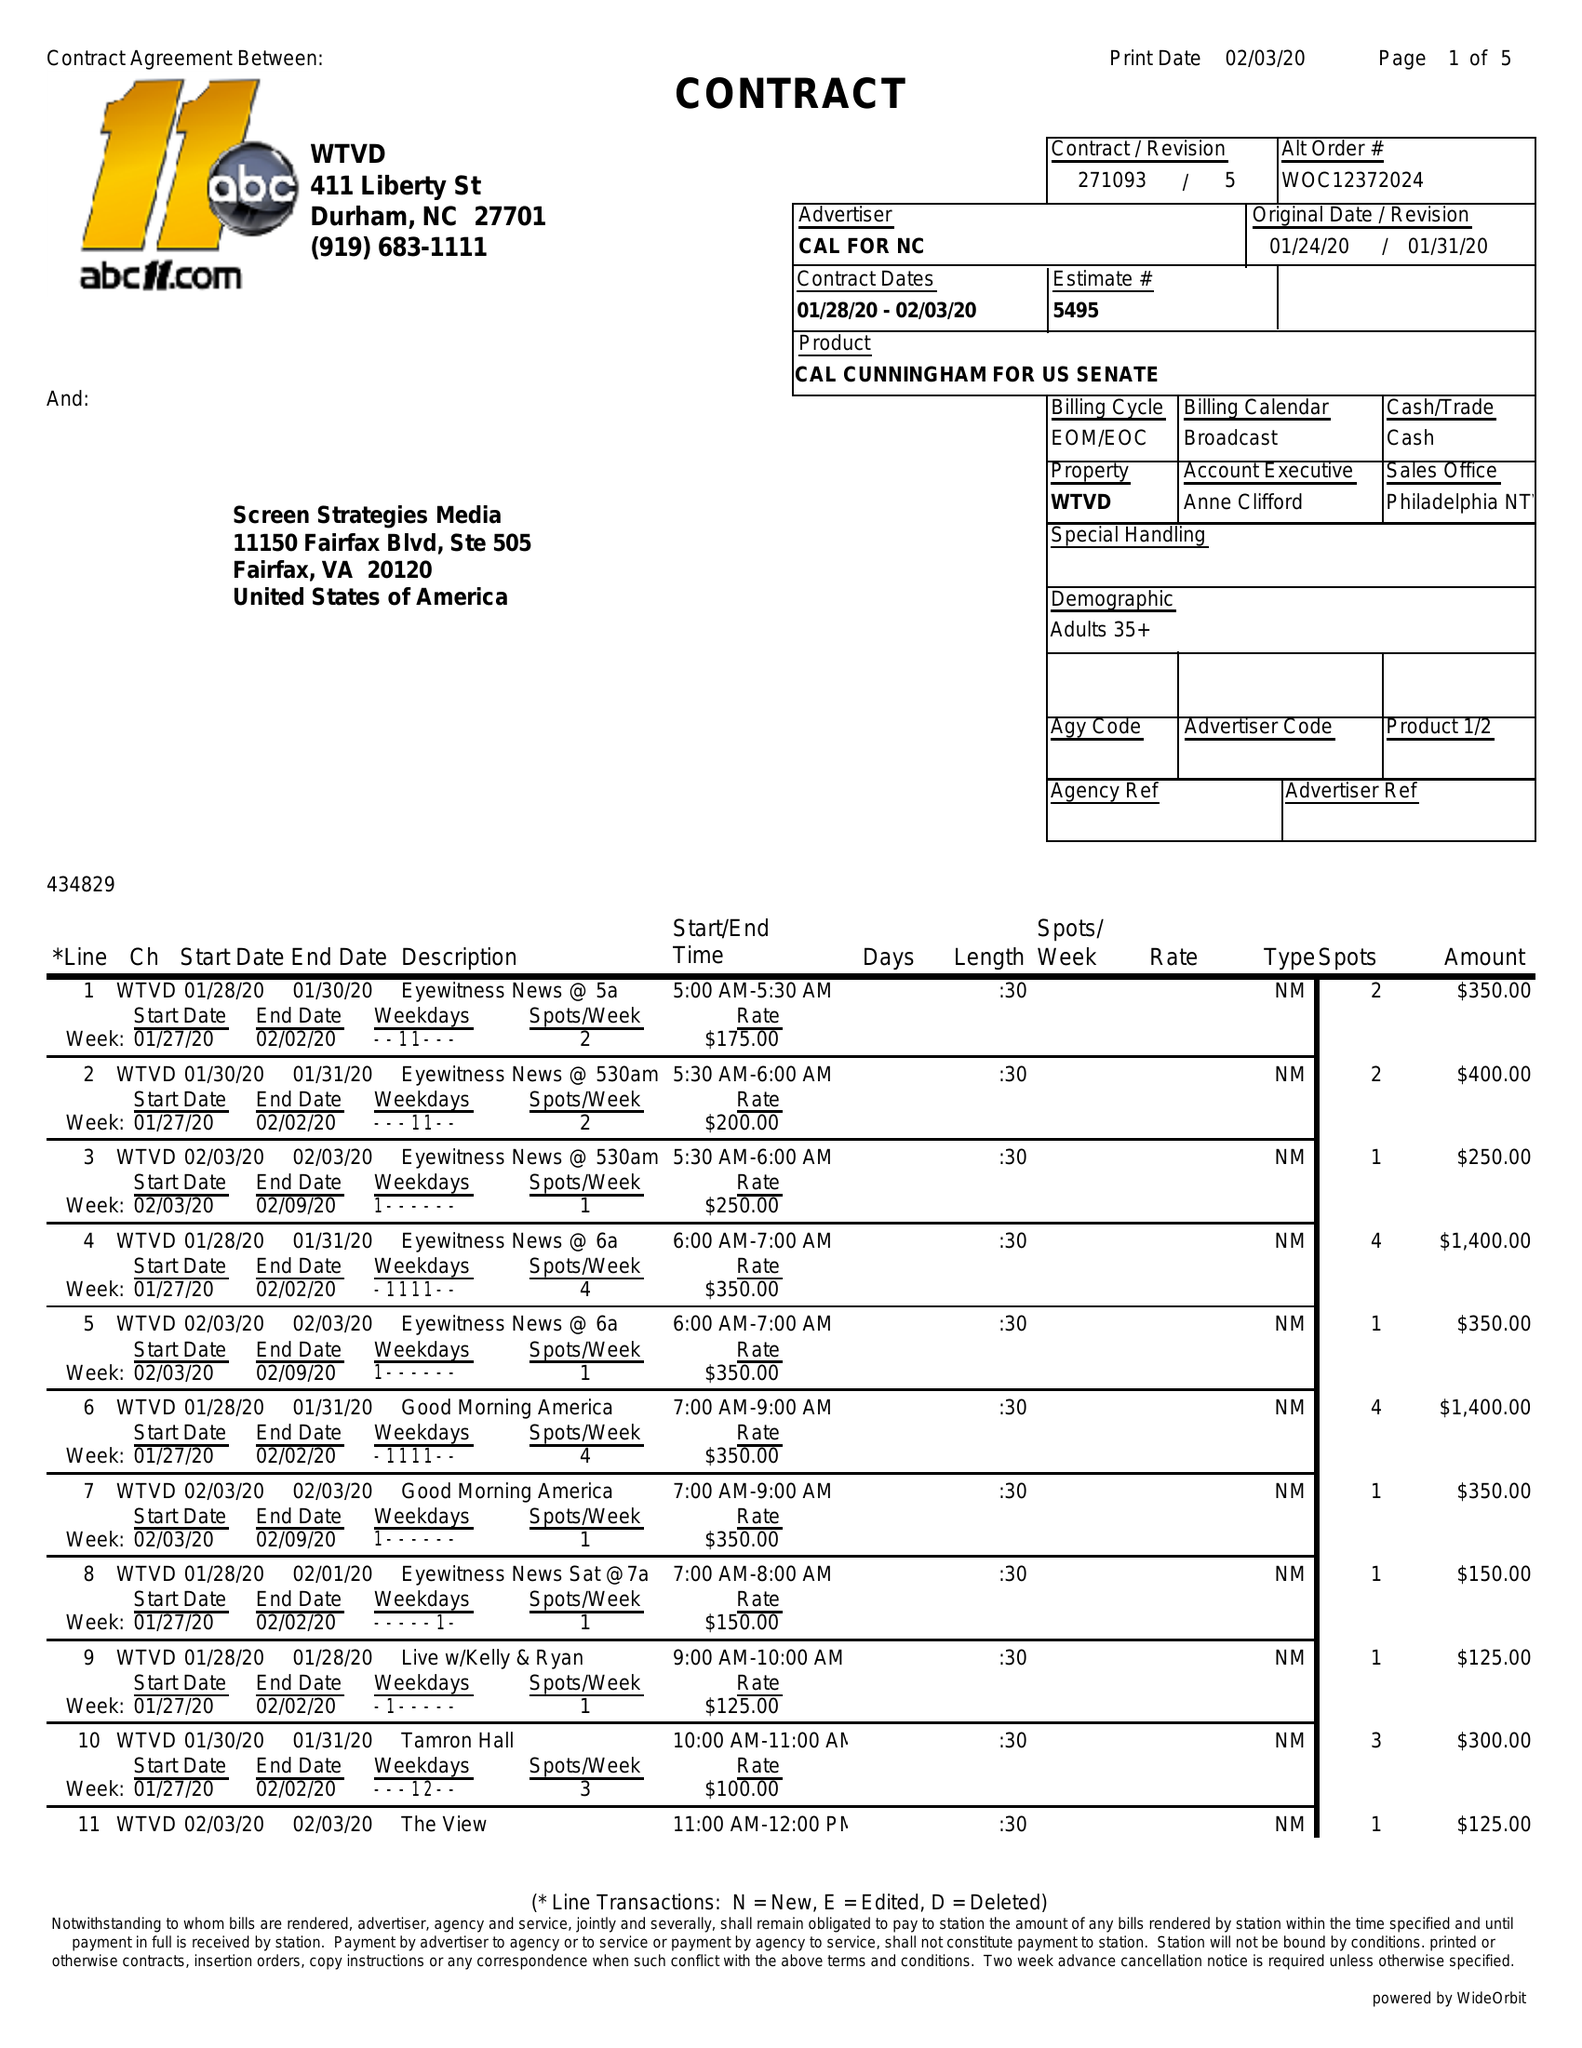What is the value for the flight_from?
Answer the question using a single word or phrase. 01/28/20 